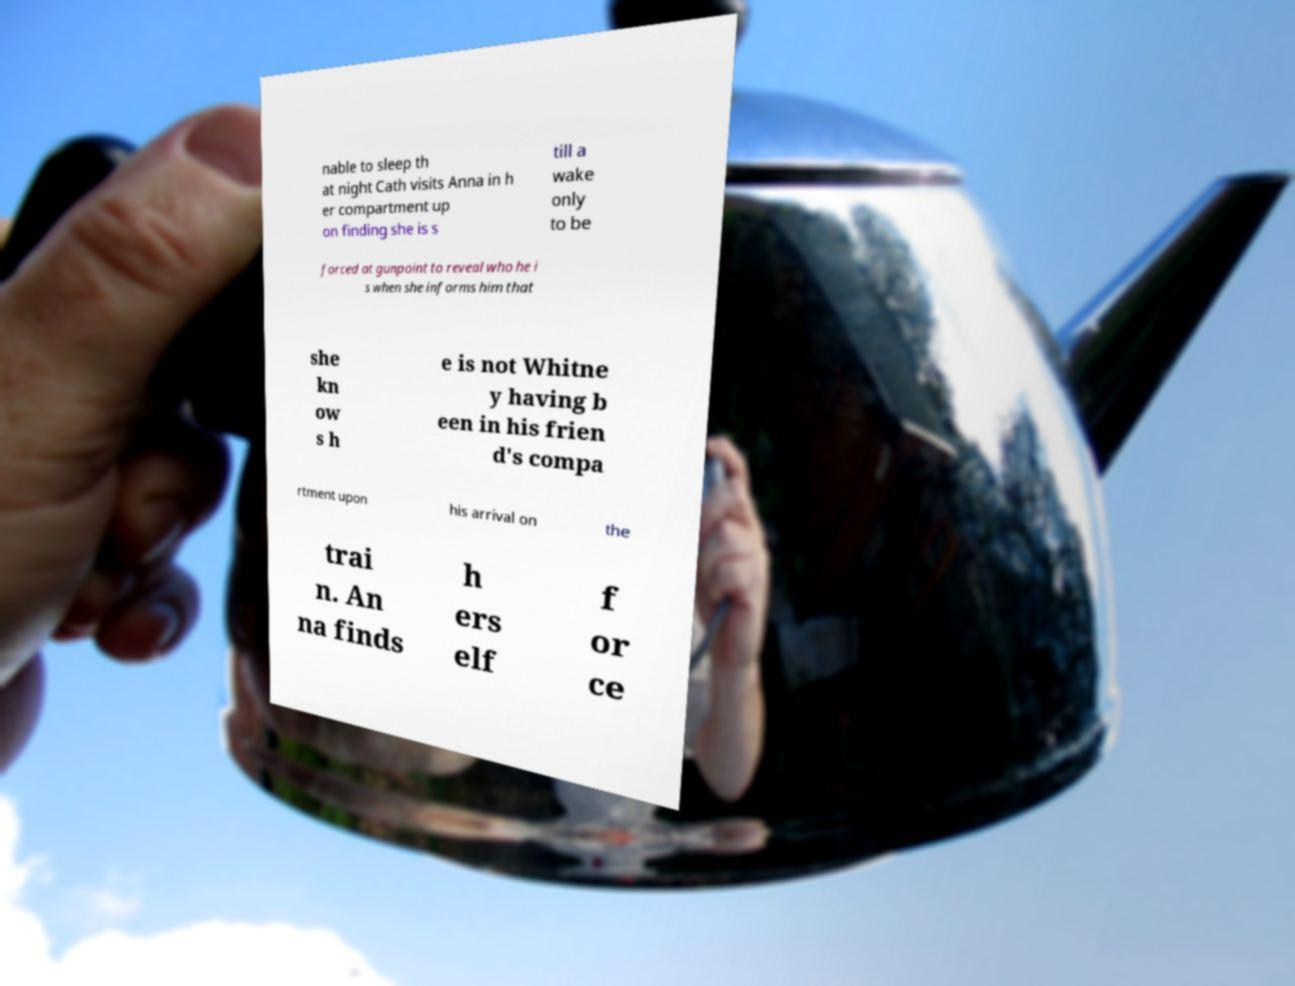For documentation purposes, I need the text within this image transcribed. Could you provide that? nable to sleep th at night Cath visits Anna in h er compartment up on finding she is s till a wake only to be forced at gunpoint to reveal who he i s when she informs him that she kn ow s h e is not Whitne y having b een in his frien d's compa rtment upon his arrival on the trai n. An na finds h ers elf f or ce 